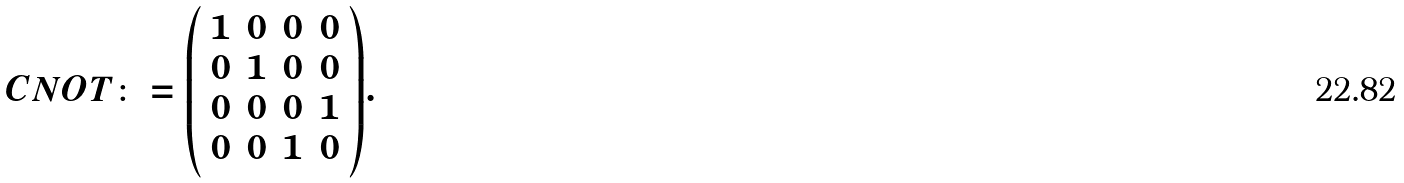<formula> <loc_0><loc_0><loc_500><loc_500>C N O T \colon = { \left ( \begin{array} { l l l l } { 1 } & { 0 } & { 0 } & { 0 } \\ { 0 } & { 1 } & { 0 } & { 0 } \\ { 0 } & { 0 } & { 0 } & { 1 } \\ { 0 } & { 0 } & { 1 } & { 0 } \end{array} \right ) } .</formula> 